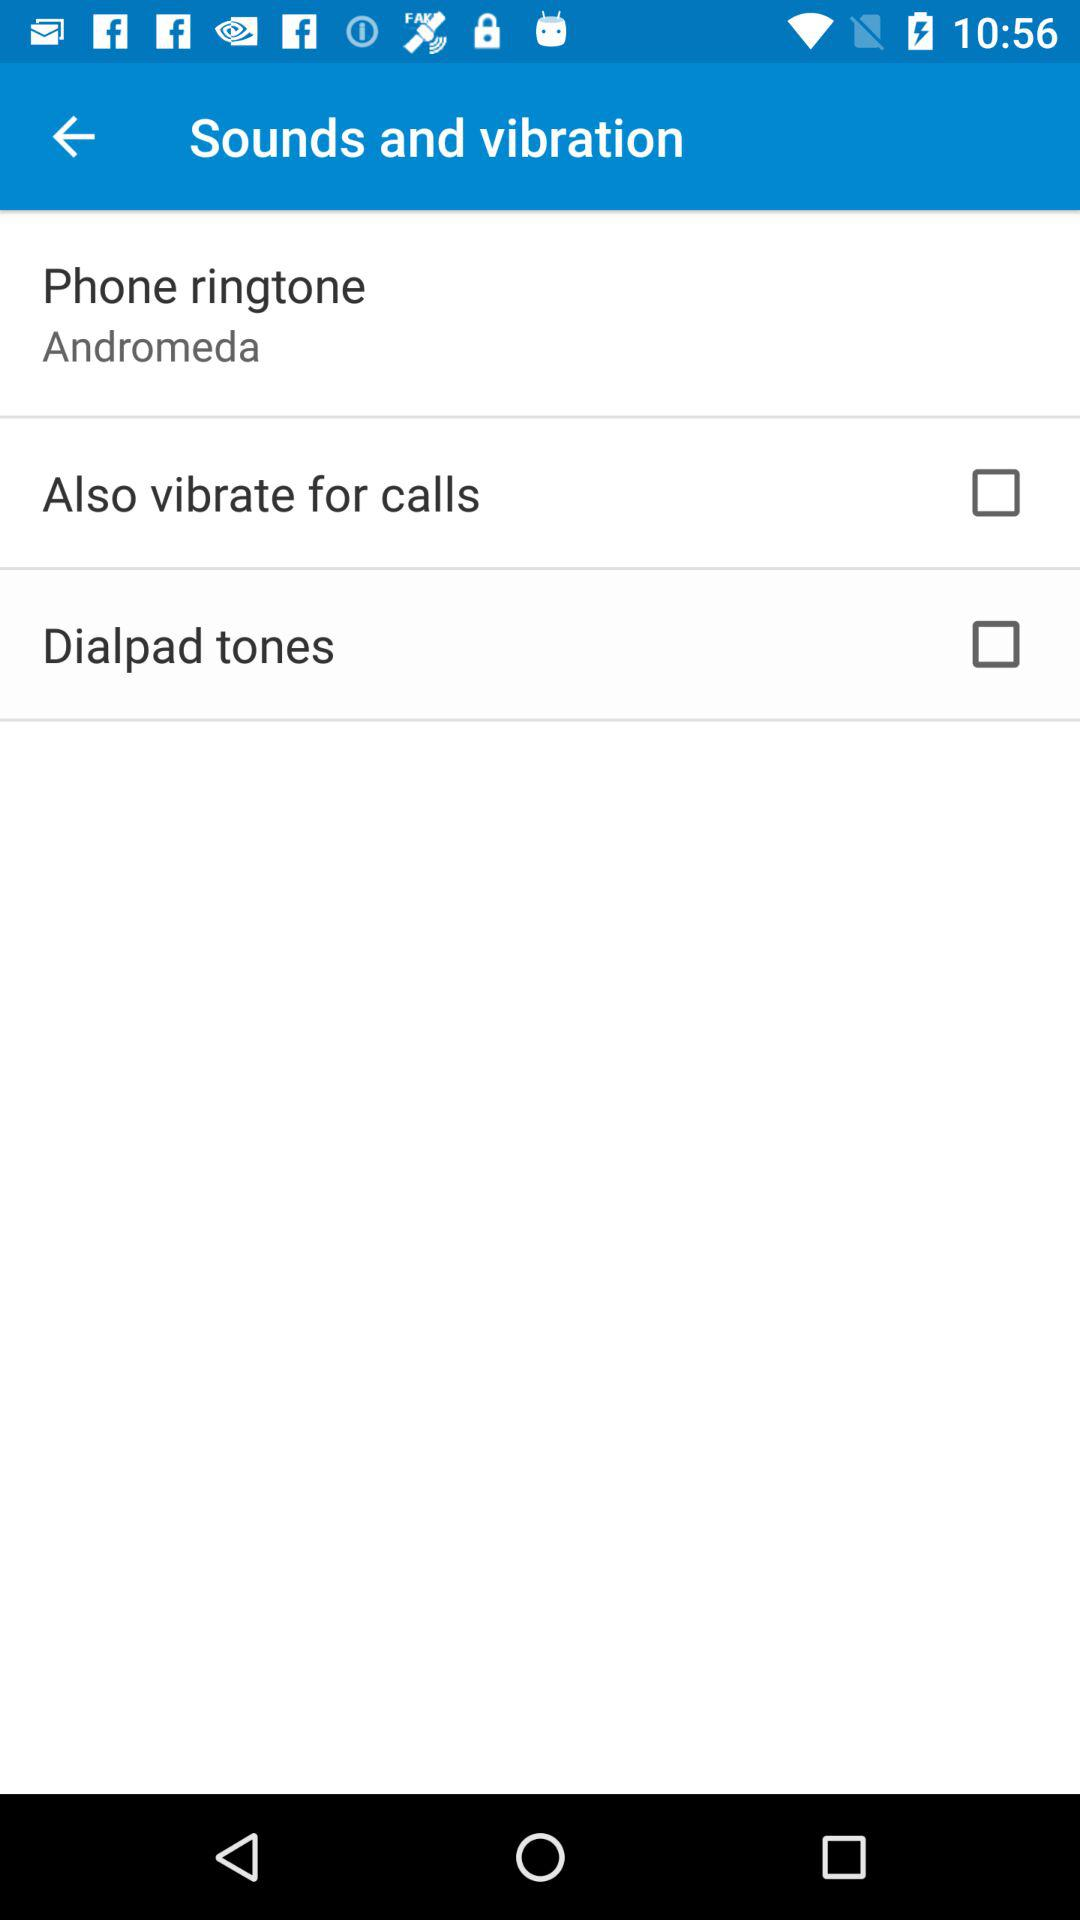What is the selected status of "Also vibrate for calls"? The status is off. 